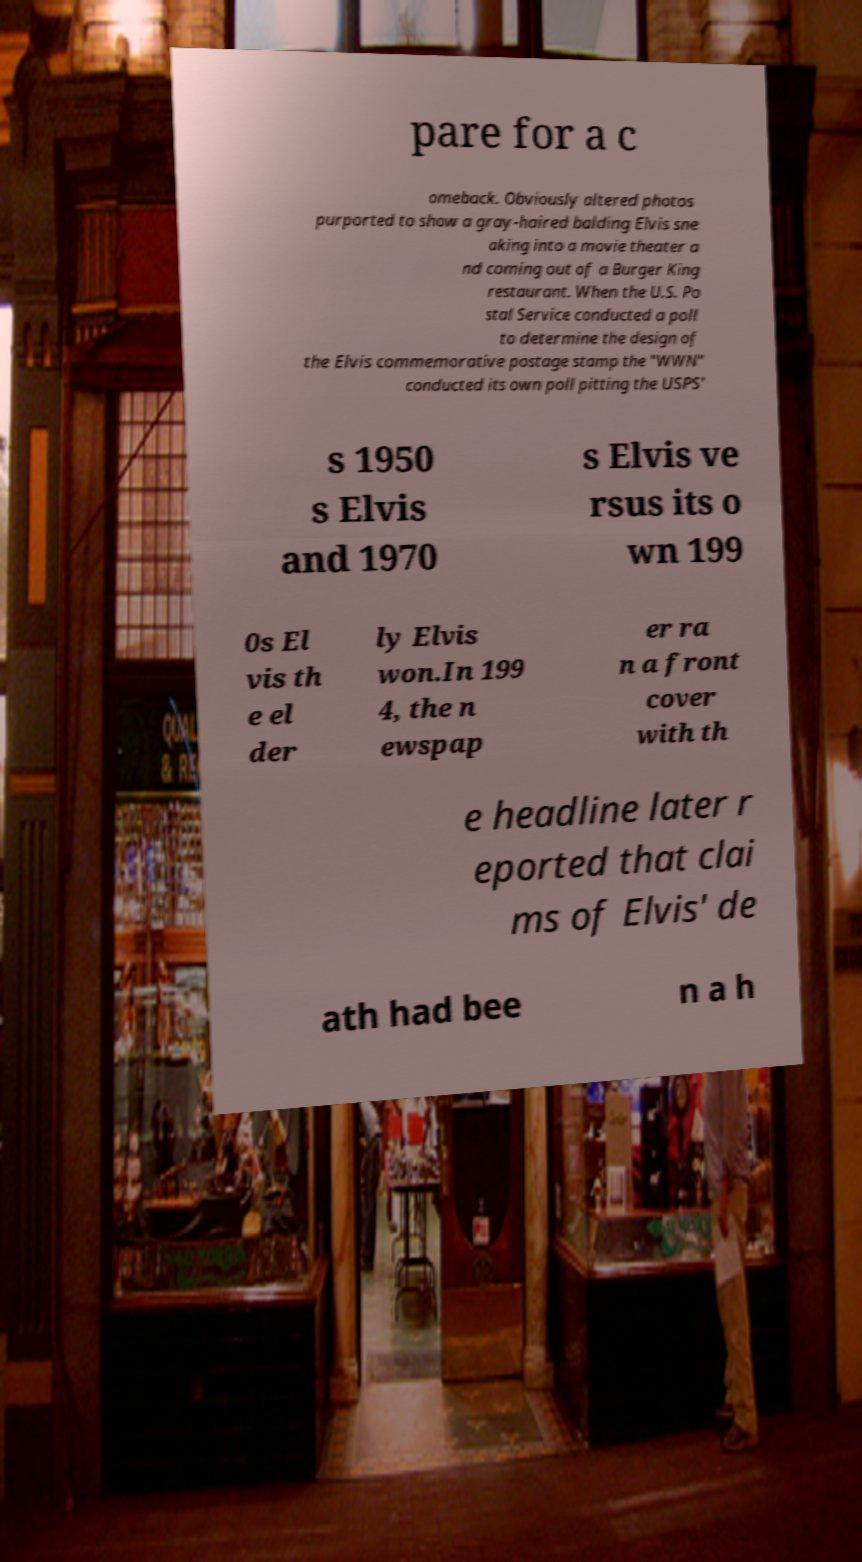For documentation purposes, I need the text within this image transcribed. Could you provide that? pare for a c omeback. Obviously altered photos purported to show a gray-haired balding Elvis sne aking into a movie theater a nd coming out of a Burger King restaurant. When the U.S. Po stal Service conducted a poll to determine the design of the Elvis commemorative postage stamp the "WWN" conducted its own poll pitting the USPS' s 1950 s Elvis and 1970 s Elvis ve rsus its o wn 199 0s El vis th e el der ly Elvis won.In 199 4, the n ewspap er ra n a front cover with th e headline later r eported that clai ms of Elvis' de ath had bee n a h 